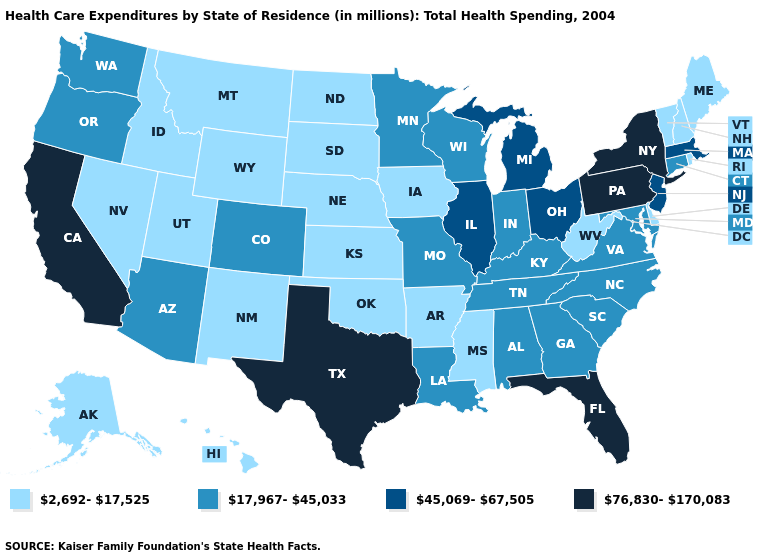Does the first symbol in the legend represent the smallest category?
Keep it brief. Yes. Does the first symbol in the legend represent the smallest category?
Write a very short answer. Yes. Is the legend a continuous bar?
Short answer required. No. Does the first symbol in the legend represent the smallest category?
Give a very brief answer. Yes. What is the value of Alaska?
Be succinct. 2,692-17,525. Does Rhode Island have the lowest value in the Northeast?
Keep it brief. Yes. Name the states that have a value in the range 2,692-17,525?
Short answer required. Alaska, Arkansas, Delaware, Hawaii, Idaho, Iowa, Kansas, Maine, Mississippi, Montana, Nebraska, Nevada, New Hampshire, New Mexico, North Dakota, Oklahoma, Rhode Island, South Dakota, Utah, Vermont, West Virginia, Wyoming. Does Alaska have the lowest value in the West?
Answer briefly. Yes. What is the value of Mississippi?
Quick response, please. 2,692-17,525. What is the value of Montana?
Be succinct. 2,692-17,525. What is the lowest value in the USA?
Short answer required. 2,692-17,525. Which states hav the highest value in the MidWest?
Write a very short answer. Illinois, Michigan, Ohio. Does the map have missing data?
Answer briefly. No. Which states hav the highest value in the Northeast?
Concise answer only. New York, Pennsylvania. Name the states that have a value in the range 17,967-45,033?
Be succinct. Alabama, Arizona, Colorado, Connecticut, Georgia, Indiana, Kentucky, Louisiana, Maryland, Minnesota, Missouri, North Carolina, Oregon, South Carolina, Tennessee, Virginia, Washington, Wisconsin. 